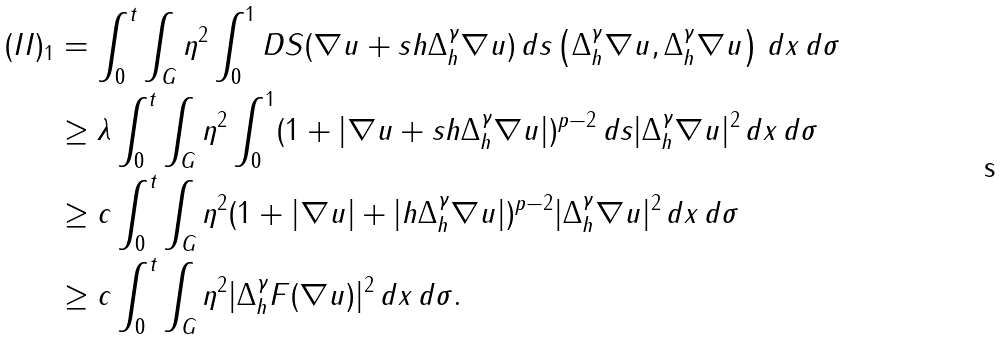Convert formula to latex. <formula><loc_0><loc_0><loc_500><loc_500>( I I ) _ { 1 } & = \int _ { 0 } ^ { t } \int _ { G } \eta ^ { 2 } \int _ { 0 } ^ { 1 } D S ( \nabla u + s h \Delta _ { h } ^ { \gamma } \nabla u ) \, d s \left ( \Delta _ { h } ^ { \gamma } \nabla u , \Delta _ { h } ^ { \gamma } \nabla u \right ) \, d x \, d \sigma \\ & \geq \lambda \int _ { 0 } ^ { t } \int _ { G } \eta ^ { 2 } \int _ { 0 } ^ { 1 } ( 1 + | \nabla u + s h \Delta _ { h } ^ { \gamma } \nabla u | ) ^ { p - 2 } \, d s | \Delta _ { h } ^ { \gamma } \nabla u | ^ { 2 } \, d x \, d \sigma \\ & \geq c \int _ { 0 } ^ { t } \int _ { G } \eta ^ { 2 } ( 1 + | \nabla u | + | h \Delta _ { h } ^ { \gamma } \nabla u | ) ^ { p - 2 } | \Delta _ { h } ^ { \gamma } \nabla u | ^ { 2 } \, d x \, d \sigma \\ & \geq c \int _ { 0 } ^ { t } \int _ { G } \eta ^ { 2 } | \Delta _ { h } ^ { \gamma } F ( \nabla u ) | ^ { 2 } \, d x \, d \sigma .</formula> 